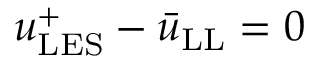<formula> <loc_0><loc_0><loc_500><loc_500>u _ { L E S } ^ { + } - \bar { u } _ { L L } = 0</formula> 